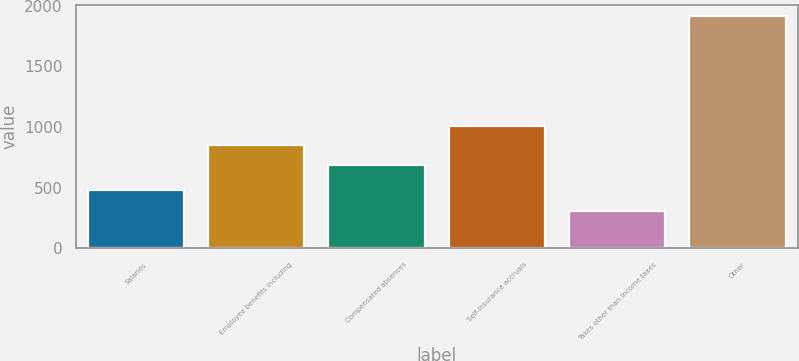Convert chart. <chart><loc_0><loc_0><loc_500><loc_500><bar_chart><fcel>Salaries<fcel>Employee benefits including<fcel>Compensated absences<fcel>Self-insurance accruals<fcel>Taxes other than income taxes<fcel>Other<nl><fcel>478<fcel>850.4<fcel>690<fcel>1010.8<fcel>311<fcel>1915<nl></chart> 